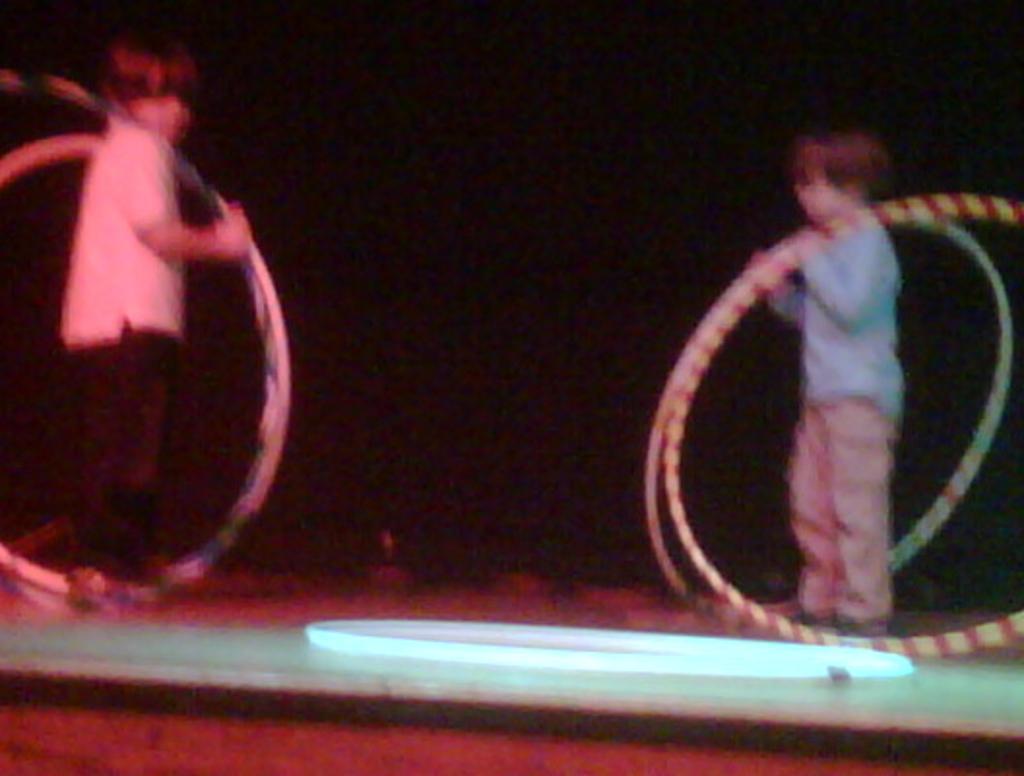Could you give a brief overview of what you see in this image? This is a blur image. On the right and left side of the image I can see two boys are standing and holding the rings in the hands. 